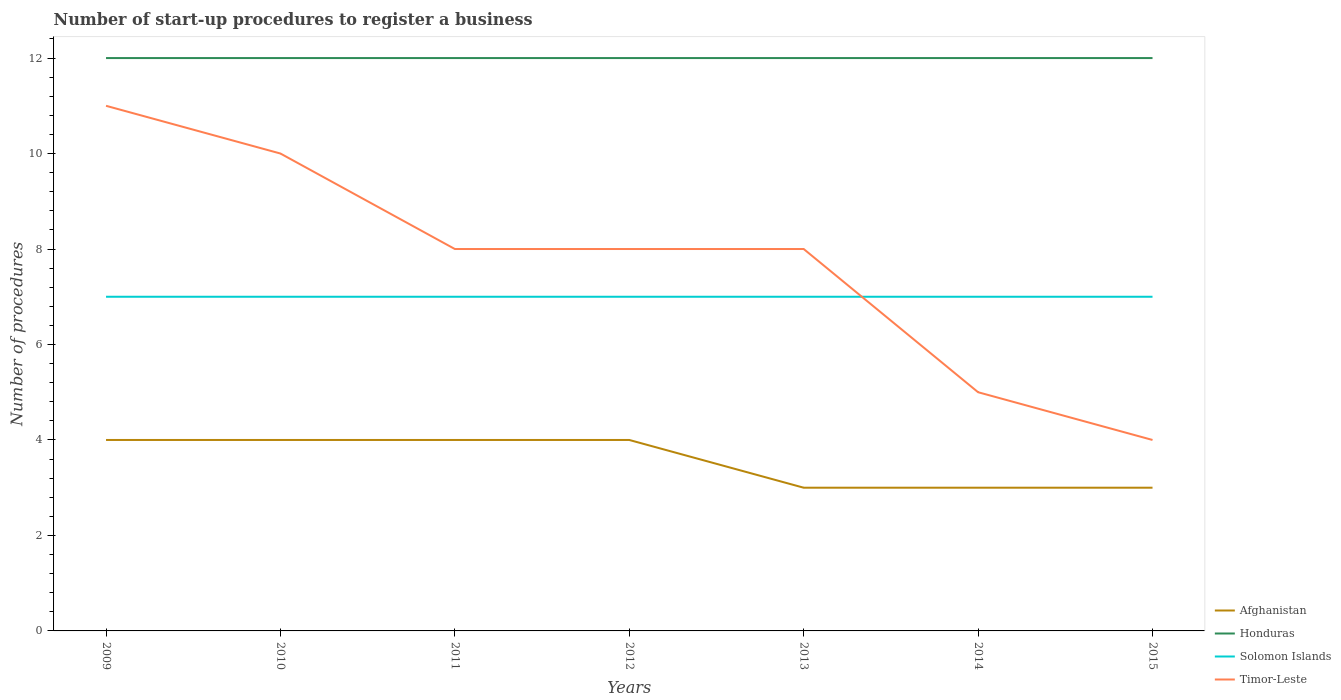Is the number of lines equal to the number of legend labels?
Ensure brevity in your answer.  Yes. Across all years, what is the maximum number of procedures required to register a business in Honduras?
Offer a very short reply. 12. In which year was the number of procedures required to register a business in Solomon Islands maximum?
Provide a short and direct response. 2009. What is the difference between the highest and the lowest number of procedures required to register a business in Honduras?
Ensure brevity in your answer.  0. How many years are there in the graph?
Provide a short and direct response. 7. Are the values on the major ticks of Y-axis written in scientific E-notation?
Provide a short and direct response. No. Does the graph contain any zero values?
Make the answer very short. No. Does the graph contain grids?
Your response must be concise. No. How many legend labels are there?
Your response must be concise. 4. How are the legend labels stacked?
Ensure brevity in your answer.  Vertical. What is the title of the graph?
Offer a very short reply. Number of start-up procedures to register a business. Does "Swaziland" appear as one of the legend labels in the graph?
Your response must be concise. No. What is the label or title of the X-axis?
Provide a short and direct response. Years. What is the label or title of the Y-axis?
Your answer should be compact. Number of procedures. What is the Number of procedures of Afghanistan in 2009?
Offer a terse response. 4. What is the Number of procedures in Honduras in 2009?
Keep it short and to the point. 12. What is the Number of procedures in Solomon Islands in 2009?
Your answer should be very brief. 7. What is the Number of procedures in Timor-Leste in 2009?
Offer a very short reply. 11. What is the Number of procedures of Afghanistan in 2010?
Give a very brief answer. 4. What is the Number of procedures of Honduras in 2010?
Offer a terse response. 12. What is the Number of procedures of Solomon Islands in 2010?
Ensure brevity in your answer.  7. What is the Number of procedures in Afghanistan in 2011?
Keep it short and to the point. 4. What is the Number of procedures of Solomon Islands in 2011?
Ensure brevity in your answer.  7. What is the Number of procedures of Timor-Leste in 2011?
Your response must be concise. 8. What is the Number of procedures of Afghanistan in 2012?
Your answer should be compact. 4. What is the Number of procedures of Solomon Islands in 2012?
Keep it short and to the point. 7. What is the Number of procedures in Honduras in 2013?
Provide a succinct answer. 12. What is the Number of procedures of Timor-Leste in 2013?
Provide a short and direct response. 8. Across all years, what is the maximum Number of procedures of Solomon Islands?
Provide a succinct answer. 7. Across all years, what is the maximum Number of procedures in Timor-Leste?
Your response must be concise. 11. Across all years, what is the minimum Number of procedures of Afghanistan?
Provide a short and direct response. 3. Across all years, what is the minimum Number of procedures in Honduras?
Ensure brevity in your answer.  12. Across all years, what is the minimum Number of procedures of Solomon Islands?
Give a very brief answer. 7. What is the total Number of procedures of Afghanistan in the graph?
Ensure brevity in your answer.  25. What is the total Number of procedures in Honduras in the graph?
Provide a short and direct response. 84. What is the total Number of procedures of Solomon Islands in the graph?
Your response must be concise. 49. What is the difference between the Number of procedures of Honduras in 2009 and that in 2011?
Provide a succinct answer. 0. What is the difference between the Number of procedures in Solomon Islands in 2009 and that in 2011?
Give a very brief answer. 0. What is the difference between the Number of procedures of Timor-Leste in 2009 and that in 2011?
Provide a short and direct response. 3. What is the difference between the Number of procedures in Afghanistan in 2009 and that in 2012?
Provide a short and direct response. 0. What is the difference between the Number of procedures in Solomon Islands in 2009 and that in 2012?
Give a very brief answer. 0. What is the difference between the Number of procedures of Honduras in 2009 and that in 2013?
Provide a short and direct response. 0. What is the difference between the Number of procedures in Timor-Leste in 2009 and that in 2013?
Offer a terse response. 3. What is the difference between the Number of procedures in Afghanistan in 2009 and that in 2014?
Give a very brief answer. 1. What is the difference between the Number of procedures in Honduras in 2009 and that in 2014?
Make the answer very short. 0. What is the difference between the Number of procedures in Solomon Islands in 2009 and that in 2014?
Your answer should be compact. 0. What is the difference between the Number of procedures in Timor-Leste in 2009 and that in 2014?
Ensure brevity in your answer.  6. What is the difference between the Number of procedures of Afghanistan in 2009 and that in 2015?
Give a very brief answer. 1. What is the difference between the Number of procedures in Honduras in 2009 and that in 2015?
Your answer should be compact. 0. What is the difference between the Number of procedures of Afghanistan in 2010 and that in 2011?
Your response must be concise. 0. What is the difference between the Number of procedures of Solomon Islands in 2010 and that in 2011?
Your response must be concise. 0. What is the difference between the Number of procedures of Timor-Leste in 2010 and that in 2011?
Your answer should be very brief. 2. What is the difference between the Number of procedures of Afghanistan in 2010 and that in 2012?
Make the answer very short. 0. What is the difference between the Number of procedures of Timor-Leste in 2010 and that in 2012?
Provide a short and direct response. 2. What is the difference between the Number of procedures in Afghanistan in 2010 and that in 2013?
Make the answer very short. 1. What is the difference between the Number of procedures of Honduras in 2010 and that in 2013?
Your answer should be very brief. 0. What is the difference between the Number of procedures of Afghanistan in 2010 and that in 2014?
Your answer should be compact. 1. What is the difference between the Number of procedures of Honduras in 2010 and that in 2014?
Your answer should be very brief. 0. What is the difference between the Number of procedures of Solomon Islands in 2010 and that in 2014?
Give a very brief answer. 0. What is the difference between the Number of procedures of Timor-Leste in 2010 and that in 2014?
Your response must be concise. 5. What is the difference between the Number of procedures in Honduras in 2010 and that in 2015?
Your answer should be very brief. 0. What is the difference between the Number of procedures in Solomon Islands in 2010 and that in 2015?
Your answer should be compact. 0. What is the difference between the Number of procedures in Timor-Leste in 2010 and that in 2015?
Give a very brief answer. 6. What is the difference between the Number of procedures of Honduras in 2011 and that in 2012?
Offer a very short reply. 0. What is the difference between the Number of procedures of Timor-Leste in 2011 and that in 2012?
Offer a very short reply. 0. What is the difference between the Number of procedures of Solomon Islands in 2011 and that in 2013?
Your answer should be compact. 0. What is the difference between the Number of procedures of Timor-Leste in 2011 and that in 2013?
Your answer should be very brief. 0. What is the difference between the Number of procedures of Afghanistan in 2011 and that in 2014?
Your response must be concise. 1. What is the difference between the Number of procedures in Honduras in 2011 and that in 2014?
Ensure brevity in your answer.  0. What is the difference between the Number of procedures of Timor-Leste in 2011 and that in 2014?
Make the answer very short. 3. What is the difference between the Number of procedures in Afghanistan in 2011 and that in 2015?
Offer a very short reply. 1. What is the difference between the Number of procedures in Honduras in 2011 and that in 2015?
Make the answer very short. 0. What is the difference between the Number of procedures of Timor-Leste in 2011 and that in 2015?
Your answer should be very brief. 4. What is the difference between the Number of procedures in Solomon Islands in 2012 and that in 2013?
Your answer should be compact. 0. What is the difference between the Number of procedures in Solomon Islands in 2012 and that in 2014?
Your answer should be very brief. 0. What is the difference between the Number of procedures in Honduras in 2012 and that in 2015?
Offer a terse response. 0. What is the difference between the Number of procedures of Solomon Islands in 2012 and that in 2015?
Your answer should be compact. 0. What is the difference between the Number of procedures in Timor-Leste in 2012 and that in 2015?
Keep it short and to the point. 4. What is the difference between the Number of procedures of Afghanistan in 2013 and that in 2014?
Provide a succinct answer. 0. What is the difference between the Number of procedures of Honduras in 2013 and that in 2014?
Ensure brevity in your answer.  0. What is the difference between the Number of procedures in Timor-Leste in 2013 and that in 2014?
Keep it short and to the point. 3. What is the difference between the Number of procedures of Honduras in 2013 and that in 2015?
Provide a short and direct response. 0. What is the difference between the Number of procedures of Solomon Islands in 2013 and that in 2015?
Your answer should be very brief. 0. What is the difference between the Number of procedures in Afghanistan in 2014 and that in 2015?
Ensure brevity in your answer.  0. What is the difference between the Number of procedures in Solomon Islands in 2014 and that in 2015?
Your answer should be compact. 0. What is the difference between the Number of procedures of Afghanistan in 2009 and the Number of procedures of Honduras in 2010?
Offer a very short reply. -8. What is the difference between the Number of procedures of Afghanistan in 2009 and the Number of procedures of Solomon Islands in 2010?
Keep it short and to the point. -3. What is the difference between the Number of procedures of Afghanistan in 2009 and the Number of procedures of Timor-Leste in 2010?
Offer a terse response. -6. What is the difference between the Number of procedures of Afghanistan in 2009 and the Number of procedures of Timor-Leste in 2011?
Your response must be concise. -4. What is the difference between the Number of procedures of Afghanistan in 2009 and the Number of procedures of Honduras in 2012?
Provide a short and direct response. -8. What is the difference between the Number of procedures in Afghanistan in 2009 and the Number of procedures in Solomon Islands in 2012?
Give a very brief answer. -3. What is the difference between the Number of procedures of Honduras in 2009 and the Number of procedures of Timor-Leste in 2012?
Keep it short and to the point. 4. What is the difference between the Number of procedures in Afghanistan in 2009 and the Number of procedures in Solomon Islands in 2013?
Offer a terse response. -3. What is the difference between the Number of procedures of Afghanistan in 2009 and the Number of procedures of Timor-Leste in 2013?
Give a very brief answer. -4. What is the difference between the Number of procedures of Honduras in 2009 and the Number of procedures of Timor-Leste in 2013?
Give a very brief answer. 4. What is the difference between the Number of procedures in Afghanistan in 2009 and the Number of procedures in Solomon Islands in 2014?
Provide a short and direct response. -3. What is the difference between the Number of procedures in Afghanistan in 2009 and the Number of procedures in Timor-Leste in 2014?
Your response must be concise. -1. What is the difference between the Number of procedures in Honduras in 2009 and the Number of procedures in Solomon Islands in 2014?
Give a very brief answer. 5. What is the difference between the Number of procedures of Honduras in 2009 and the Number of procedures of Timor-Leste in 2014?
Your answer should be very brief. 7. What is the difference between the Number of procedures in Afghanistan in 2009 and the Number of procedures in Solomon Islands in 2015?
Make the answer very short. -3. What is the difference between the Number of procedures in Afghanistan in 2009 and the Number of procedures in Timor-Leste in 2015?
Your response must be concise. 0. What is the difference between the Number of procedures of Honduras in 2009 and the Number of procedures of Solomon Islands in 2015?
Provide a short and direct response. 5. What is the difference between the Number of procedures in Honduras in 2009 and the Number of procedures in Timor-Leste in 2015?
Provide a short and direct response. 8. What is the difference between the Number of procedures of Afghanistan in 2010 and the Number of procedures of Honduras in 2011?
Your answer should be very brief. -8. What is the difference between the Number of procedures in Afghanistan in 2010 and the Number of procedures in Timor-Leste in 2011?
Offer a very short reply. -4. What is the difference between the Number of procedures in Honduras in 2010 and the Number of procedures in Timor-Leste in 2011?
Give a very brief answer. 4. What is the difference between the Number of procedures in Solomon Islands in 2010 and the Number of procedures in Timor-Leste in 2011?
Make the answer very short. -1. What is the difference between the Number of procedures in Afghanistan in 2010 and the Number of procedures in Honduras in 2012?
Provide a short and direct response. -8. What is the difference between the Number of procedures in Honduras in 2010 and the Number of procedures in Timor-Leste in 2012?
Ensure brevity in your answer.  4. What is the difference between the Number of procedures in Solomon Islands in 2010 and the Number of procedures in Timor-Leste in 2012?
Provide a short and direct response. -1. What is the difference between the Number of procedures of Afghanistan in 2010 and the Number of procedures of Honduras in 2013?
Make the answer very short. -8. What is the difference between the Number of procedures of Honduras in 2010 and the Number of procedures of Timor-Leste in 2013?
Your response must be concise. 4. What is the difference between the Number of procedures of Afghanistan in 2010 and the Number of procedures of Honduras in 2014?
Ensure brevity in your answer.  -8. What is the difference between the Number of procedures in Afghanistan in 2010 and the Number of procedures in Solomon Islands in 2014?
Your answer should be very brief. -3. What is the difference between the Number of procedures of Honduras in 2010 and the Number of procedures of Timor-Leste in 2014?
Offer a very short reply. 7. What is the difference between the Number of procedures in Solomon Islands in 2010 and the Number of procedures in Timor-Leste in 2014?
Provide a succinct answer. 2. What is the difference between the Number of procedures of Honduras in 2010 and the Number of procedures of Solomon Islands in 2015?
Your response must be concise. 5. What is the difference between the Number of procedures of Honduras in 2010 and the Number of procedures of Timor-Leste in 2015?
Offer a terse response. 8. What is the difference between the Number of procedures in Solomon Islands in 2010 and the Number of procedures in Timor-Leste in 2015?
Provide a succinct answer. 3. What is the difference between the Number of procedures in Afghanistan in 2011 and the Number of procedures in Solomon Islands in 2012?
Keep it short and to the point. -3. What is the difference between the Number of procedures in Afghanistan in 2011 and the Number of procedures in Timor-Leste in 2012?
Your response must be concise. -4. What is the difference between the Number of procedures in Honduras in 2011 and the Number of procedures in Solomon Islands in 2012?
Keep it short and to the point. 5. What is the difference between the Number of procedures in Afghanistan in 2011 and the Number of procedures in Solomon Islands in 2013?
Make the answer very short. -3. What is the difference between the Number of procedures of Honduras in 2011 and the Number of procedures of Timor-Leste in 2013?
Offer a very short reply. 4. What is the difference between the Number of procedures in Solomon Islands in 2011 and the Number of procedures in Timor-Leste in 2013?
Your answer should be very brief. -1. What is the difference between the Number of procedures in Afghanistan in 2011 and the Number of procedures in Honduras in 2014?
Give a very brief answer. -8. What is the difference between the Number of procedures of Afghanistan in 2011 and the Number of procedures of Solomon Islands in 2014?
Offer a terse response. -3. What is the difference between the Number of procedures of Afghanistan in 2011 and the Number of procedures of Timor-Leste in 2014?
Give a very brief answer. -1. What is the difference between the Number of procedures of Honduras in 2011 and the Number of procedures of Timor-Leste in 2014?
Provide a succinct answer. 7. What is the difference between the Number of procedures in Solomon Islands in 2011 and the Number of procedures in Timor-Leste in 2014?
Your answer should be compact. 2. What is the difference between the Number of procedures in Afghanistan in 2011 and the Number of procedures in Honduras in 2015?
Give a very brief answer. -8. What is the difference between the Number of procedures in Afghanistan in 2011 and the Number of procedures in Solomon Islands in 2015?
Ensure brevity in your answer.  -3. What is the difference between the Number of procedures of Afghanistan in 2011 and the Number of procedures of Timor-Leste in 2015?
Give a very brief answer. 0. What is the difference between the Number of procedures in Honduras in 2011 and the Number of procedures in Solomon Islands in 2015?
Give a very brief answer. 5. What is the difference between the Number of procedures in Afghanistan in 2012 and the Number of procedures in Timor-Leste in 2013?
Offer a terse response. -4. What is the difference between the Number of procedures in Honduras in 2012 and the Number of procedures in Solomon Islands in 2013?
Provide a succinct answer. 5. What is the difference between the Number of procedures of Honduras in 2012 and the Number of procedures of Timor-Leste in 2013?
Make the answer very short. 4. What is the difference between the Number of procedures in Solomon Islands in 2012 and the Number of procedures in Timor-Leste in 2013?
Give a very brief answer. -1. What is the difference between the Number of procedures in Afghanistan in 2012 and the Number of procedures in Honduras in 2014?
Provide a succinct answer. -8. What is the difference between the Number of procedures of Afghanistan in 2012 and the Number of procedures of Solomon Islands in 2014?
Keep it short and to the point. -3. What is the difference between the Number of procedures in Afghanistan in 2012 and the Number of procedures in Timor-Leste in 2014?
Make the answer very short. -1. What is the difference between the Number of procedures of Honduras in 2012 and the Number of procedures of Timor-Leste in 2014?
Give a very brief answer. 7. What is the difference between the Number of procedures of Afghanistan in 2012 and the Number of procedures of Solomon Islands in 2015?
Offer a very short reply. -3. What is the difference between the Number of procedures of Honduras in 2012 and the Number of procedures of Timor-Leste in 2015?
Ensure brevity in your answer.  8. What is the difference between the Number of procedures of Solomon Islands in 2012 and the Number of procedures of Timor-Leste in 2015?
Ensure brevity in your answer.  3. What is the difference between the Number of procedures of Afghanistan in 2013 and the Number of procedures of Solomon Islands in 2014?
Offer a very short reply. -4. What is the difference between the Number of procedures of Afghanistan in 2013 and the Number of procedures of Timor-Leste in 2014?
Provide a succinct answer. -2. What is the difference between the Number of procedures in Honduras in 2013 and the Number of procedures in Solomon Islands in 2014?
Offer a very short reply. 5. What is the difference between the Number of procedures of Solomon Islands in 2013 and the Number of procedures of Timor-Leste in 2014?
Your answer should be compact. 2. What is the difference between the Number of procedures in Afghanistan in 2013 and the Number of procedures in Honduras in 2015?
Give a very brief answer. -9. What is the difference between the Number of procedures of Afghanistan in 2014 and the Number of procedures of Solomon Islands in 2015?
Your answer should be compact. -4. What is the difference between the Number of procedures in Honduras in 2014 and the Number of procedures in Timor-Leste in 2015?
Offer a terse response. 8. What is the average Number of procedures of Afghanistan per year?
Give a very brief answer. 3.57. What is the average Number of procedures of Solomon Islands per year?
Keep it short and to the point. 7. What is the average Number of procedures of Timor-Leste per year?
Your answer should be very brief. 7.71. In the year 2009, what is the difference between the Number of procedures of Afghanistan and Number of procedures of Honduras?
Offer a terse response. -8. In the year 2009, what is the difference between the Number of procedures of Afghanistan and Number of procedures of Solomon Islands?
Your response must be concise. -3. In the year 2010, what is the difference between the Number of procedures of Afghanistan and Number of procedures of Honduras?
Offer a terse response. -8. In the year 2010, what is the difference between the Number of procedures of Afghanistan and Number of procedures of Timor-Leste?
Your response must be concise. -6. In the year 2010, what is the difference between the Number of procedures of Honduras and Number of procedures of Solomon Islands?
Provide a short and direct response. 5. In the year 2011, what is the difference between the Number of procedures in Afghanistan and Number of procedures in Honduras?
Your answer should be compact. -8. In the year 2011, what is the difference between the Number of procedures of Afghanistan and Number of procedures of Timor-Leste?
Ensure brevity in your answer.  -4. In the year 2011, what is the difference between the Number of procedures in Honduras and Number of procedures in Solomon Islands?
Your answer should be very brief. 5. In the year 2011, what is the difference between the Number of procedures of Honduras and Number of procedures of Timor-Leste?
Your answer should be compact. 4. In the year 2012, what is the difference between the Number of procedures of Afghanistan and Number of procedures of Solomon Islands?
Make the answer very short. -3. In the year 2012, what is the difference between the Number of procedures in Afghanistan and Number of procedures in Timor-Leste?
Give a very brief answer. -4. In the year 2012, what is the difference between the Number of procedures in Honduras and Number of procedures in Timor-Leste?
Make the answer very short. 4. In the year 2013, what is the difference between the Number of procedures of Afghanistan and Number of procedures of Solomon Islands?
Your response must be concise. -4. In the year 2013, what is the difference between the Number of procedures in Afghanistan and Number of procedures in Timor-Leste?
Ensure brevity in your answer.  -5. In the year 2013, what is the difference between the Number of procedures in Honduras and Number of procedures in Solomon Islands?
Your answer should be compact. 5. In the year 2013, what is the difference between the Number of procedures in Solomon Islands and Number of procedures in Timor-Leste?
Your answer should be compact. -1. In the year 2014, what is the difference between the Number of procedures of Afghanistan and Number of procedures of Solomon Islands?
Ensure brevity in your answer.  -4. In the year 2014, what is the difference between the Number of procedures of Honduras and Number of procedures of Solomon Islands?
Keep it short and to the point. 5. In the year 2014, what is the difference between the Number of procedures in Solomon Islands and Number of procedures in Timor-Leste?
Offer a terse response. 2. In the year 2015, what is the difference between the Number of procedures in Afghanistan and Number of procedures in Honduras?
Your answer should be compact. -9. In the year 2015, what is the difference between the Number of procedures in Afghanistan and Number of procedures in Timor-Leste?
Your response must be concise. -1. What is the ratio of the Number of procedures in Solomon Islands in 2009 to that in 2010?
Provide a short and direct response. 1. What is the ratio of the Number of procedures in Afghanistan in 2009 to that in 2011?
Your answer should be compact. 1. What is the ratio of the Number of procedures in Timor-Leste in 2009 to that in 2011?
Provide a short and direct response. 1.38. What is the ratio of the Number of procedures in Honduras in 2009 to that in 2012?
Give a very brief answer. 1. What is the ratio of the Number of procedures in Timor-Leste in 2009 to that in 2012?
Offer a terse response. 1.38. What is the ratio of the Number of procedures of Solomon Islands in 2009 to that in 2013?
Your response must be concise. 1. What is the ratio of the Number of procedures in Timor-Leste in 2009 to that in 2013?
Keep it short and to the point. 1.38. What is the ratio of the Number of procedures in Afghanistan in 2009 to that in 2014?
Offer a terse response. 1.33. What is the ratio of the Number of procedures of Solomon Islands in 2009 to that in 2014?
Provide a short and direct response. 1. What is the ratio of the Number of procedures in Timor-Leste in 2009 to that in 2014?
Offer a terse response. 2.2. What is the ratio of the Number of procedures of Solomon Islands in 2009 to that in 2015?
Your response must be concise. 1. What is the ratio of the Number of procedures in Timor-Leste in 2009 to that in 2015?
Keep it short and to the point. 2.75. What is the ratio of the Number of procedures of Afghanistan in 2010 to that in 2011?
Provide a short and direct response. 1. What is the ratio of the Number of procedures of Honduras in 2010 to that in 2011?
Offer a very short reply. 1. What is the ratio of the Number of procedures of Solomon Islands in 2010 to that in 2011?
Your answer should be compact. 1. What is the ratio of the Number of procedures in Honduras in 2010 to that in 2012?
Your answer should be very brief. 1. What is the ratio of the Number of procedures of Solomon Islands in 2010 to that in 2012?
Make the answer very short. 1. What is the ratio of the Number of procedures in Timor-Leste in 2010 to that in 2012?
Provide a succinct answer. 1.25. What is the ratio of the Number of procedures of Afghanistan in 2010 to that in 2013?
Keep it short and to the point. 1.33. What is the ratio of the Number of procedures of Solomon Islands in 2010 to that in 2013?
Keep it short and to the point. 1. What is the ratio of the Number of procedures in Timor-Leste in 2010 to that in 2013?
Make the answer very short. 1.25. What is the ratio of the Number of procedures of Timor-Leste in 2010 to that in 2014?
Provide a short and direct response. 2. What is the ratio of the Number of procedures of Afghanistan in 2010 to that in 2015?
Offer a terse response. 1.33. What is the ratio of the Number of procedures in Honduras in 2010 to that in 2015?
Give a very brief answer. 1. What is the ratio of the Number of procedures in Timor-Leste in 2010 to that in 2015?
Offer a terse response. 2.5. What is the ratio of the Number of procedures of Solomon Islands in 2011 to that in 2012?
Your answer should be very brief. 1. What is the ratio of the Number of procedures of Afghanistan in 2011 to that in 2013?
Give a very brief answer. 1.33. What is the ratio of the Number of procedures in Timor-Leste in 2011 to that in 2013?
Your answer should be very brief. 1. What is the ratio of the Number of procedures of Afghanistan in 2011 to that in 2014?
Provide a short and direct response. 1.33. What is the ratio of the Number of procedures of Honduras in 2011 to that in 2014?
Give a very brief answer. 1. What is the ratio of the Number of procedures in Solomon Islands in 2011 to that in 2014?
Keep it short and to the point. 1. What is the ratio of the Number of procedures in Timor-Leste in 2011 to that in 2014?
Offer a terse response. 1.6. What is the ratio of the Number of procedures of Afghanistan in 2011 to that in 2015?
Provide a short and direct response. 1.33. What is the ratio of the Number of procedures in Honduras in 2011 to that in 2015?
Provide a succinct answer. 1. What is the ratio of the Number of procedures of Timor-Leste in 2011 to that in 2015?
Keep it short and to the point. 2. What is the ratio of the Number of procedures in Afghanistan in 2012 to that in 2013?
Ensure brevity in your answer.  1.33. What is the ratio of the Number of procedures of Honduras in 2012 to that in 2013?
Ensure brevity in your answer.  1. What is the ratio of the Number of procedures in Timor-Leste in 2012 to that in 2013?
Give a very brief answer. 1. What is the ratio of the Number of procedures in Honduras in 2012 to that in 2014?
Provide a succinct answer. 1. What is the ratio of the Number of procedures in Solomon Islands in 2012 to that in 2014?
Ensure brevity in your answer.  1. What is the ratio of the Number of procedures in Timor-Leste in 2012 to that in 2014?
Offer a very short reply. 1.6. What is the ratio of the Number of procedures in Afghanistan in 2012 to that in 2015?
Offer a very short reply. 1.33. What is the ratio of the Number of procedures in Timor-Leste in 2012 to that in 2015?
Make the answer very short. 2. What is the ratio of the Number of procedures in Afghanistan in 2013 to that in 2014?
Provide a succinct answer. 1. What is the ratio of the Number of procedures of Honduras in 2013 to that in 2014?
Ensure brevity in your answer.  1. What is the ratio of the Number of procedures in Afghanistan in 2013 to that in 2015?
Keep it short and to the point. 1. What is the ratio of the Number of procedures in Honduras in 2013 to that in 2015?
Keep it short and to the point. 1. What is the ratio of the Number of procedures of Solomon Islands in 2013 to that in 2015?
Make the answer very short. 1. What is the ratio of the Number of procedures in Solomon Islands in 2014 to that in 2015?
Provide a succinct answer. 1. What is the ratio of the Number of procedures in Timor-Leste in 2014 to that in 2015?
Your response must be concise. 1.25. What is the difference between the highest and the lowest Number of procedures in Solomon Islands?
Your answer should be compact. 0. What is the difference between the highest and the lowest Number of procedures in Timor-Leste?
Offer a very short reply. 7. 